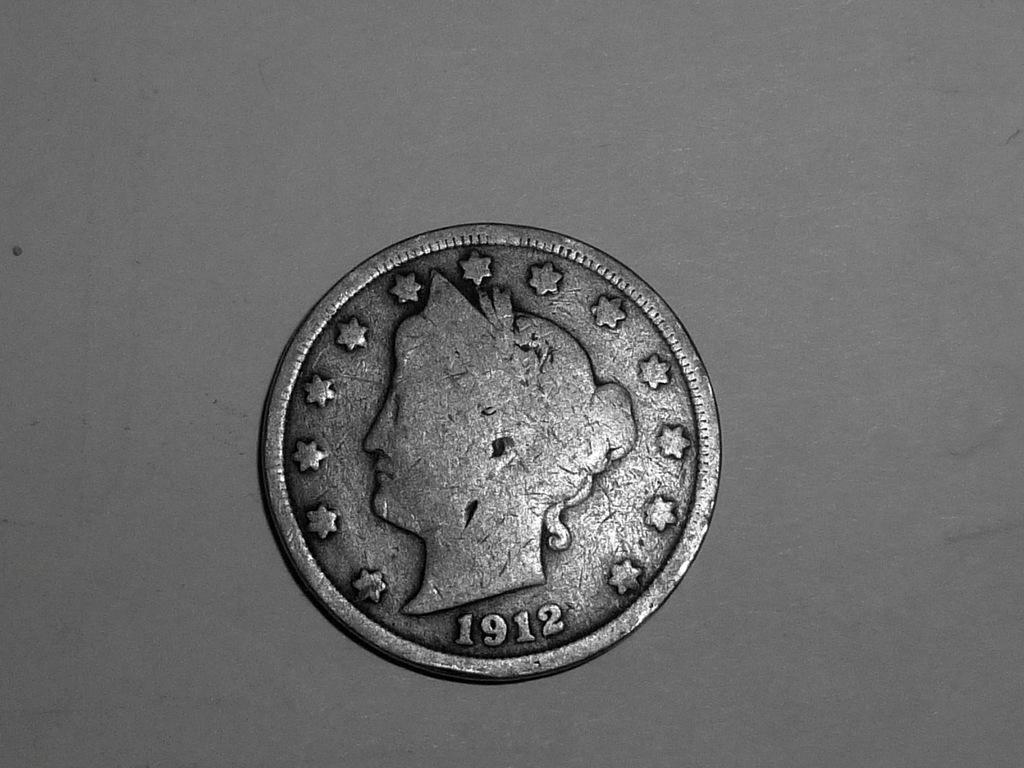<image>
Create a compact narrative representing the image presented. An old coin that has the year 1912 on it 